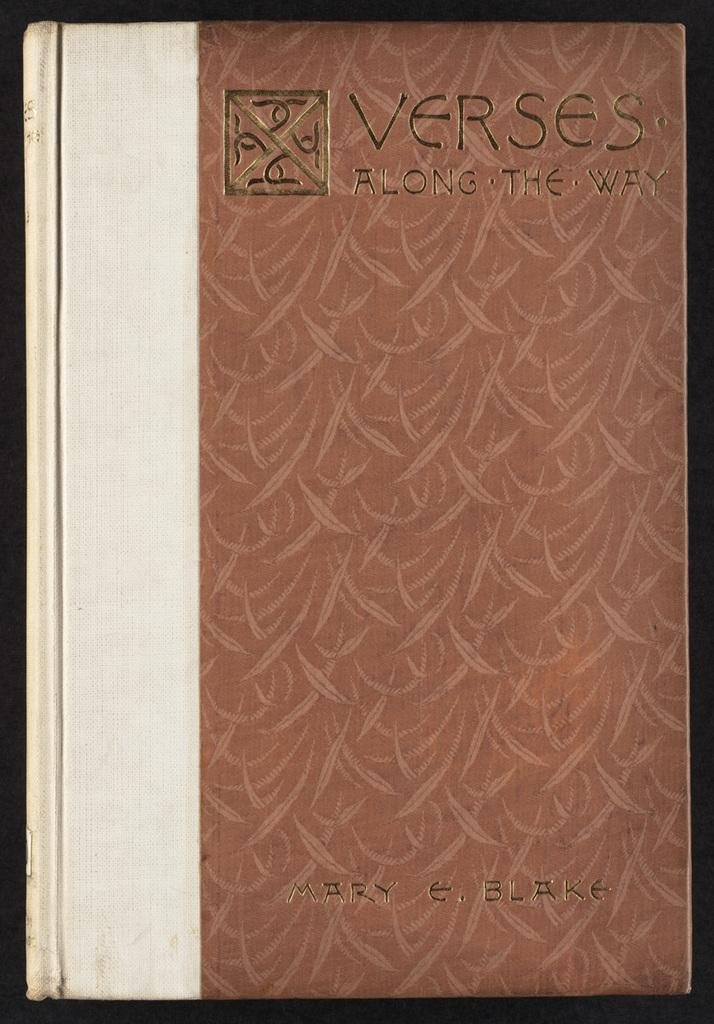<image>
Give a short and clear explanation of the subsequent image. Mary E. Blake write a book called Verses Along The Way with a red covere 